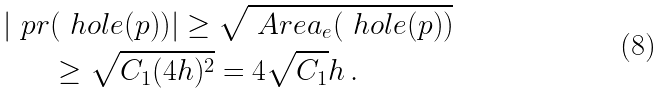<formula> <loc_0><loc_0><loc_500><loc_500>| \ p r & ( \ h o l e ( p ) ) | \geq \sqrt { \ A r e a _ { e } ( \ h o l e ( p ) ) } \\ & \geq \sqrt { C _ { 1 } ( 4 h ) ^ { 2 } } = 4 \sqrt { C _ { 1 } } h \, .</formula> 